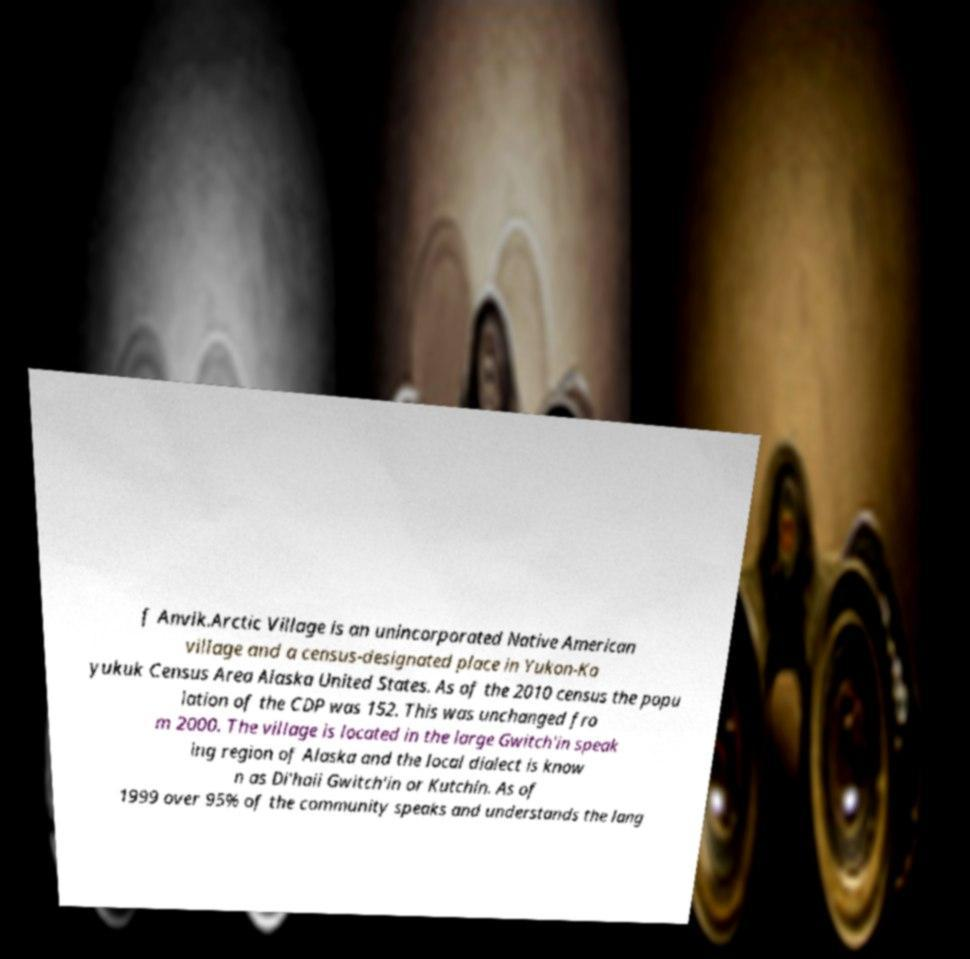What messages or text are displayed in this image? I need them in a readable, typed format. f Anvik.Arctic Village is an unincorporated Native American village and a census-designated place in Yukon-Ko yukuk Census Area Alaska United States. As of the 2010 census the popu lation of the CDP was 152. This was unchanged fro m 2000. The village is located in the large Gwitch'in speak ing region of Alaska and the local dialect is know n as Di'haii Gwitch'in or Kutchin. As of 1999 over 95% of the community speaks and understands the lang 